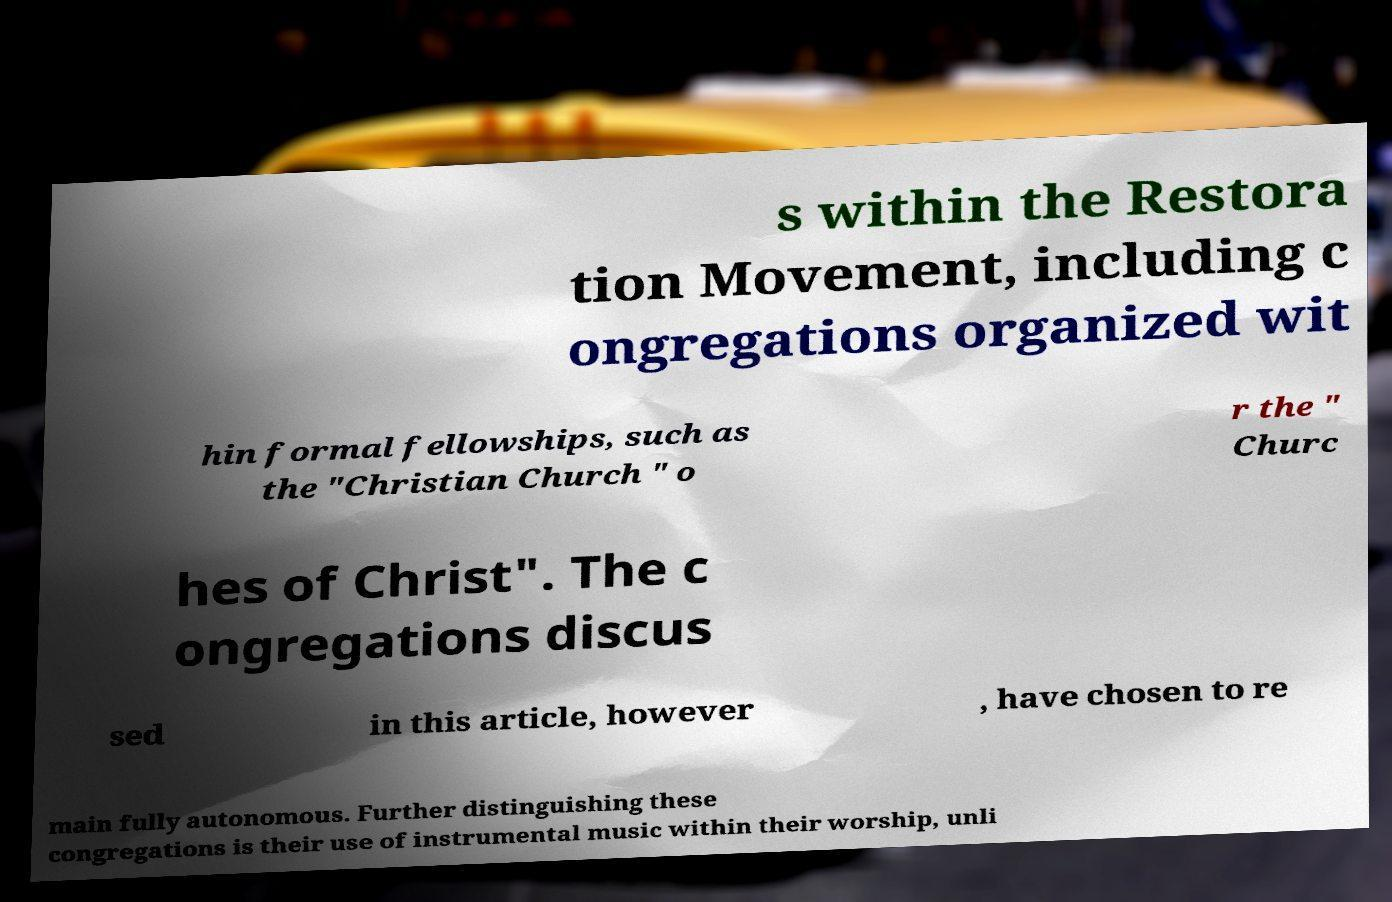For documentation purposes, I need the text within this image transcribed. Could you provide that? s within the Restora tion Movement, including c ongregations organized wit hin formal fellowships, such as the "Christian Church " o r the " Churc hes of Christ". The c ongregations discus sed in this article, however , have chosen to re main fully autonomous. Further distinguishing these congregations is their use of instrumental music within their worship, unli 